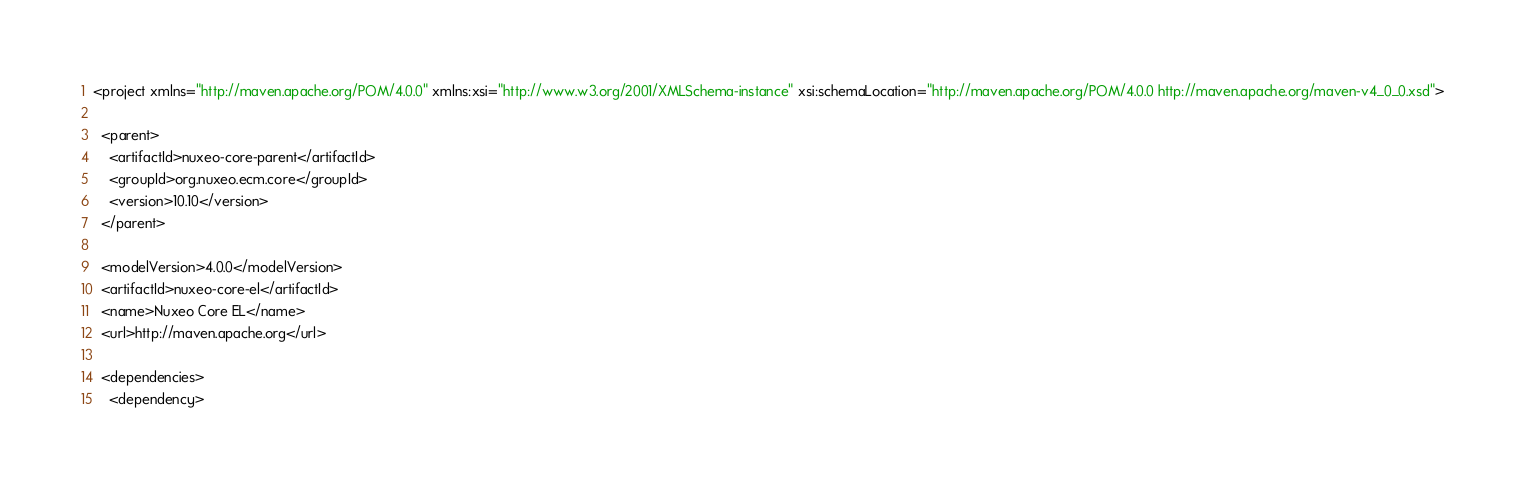Convert code to text. <code><loc_0><loc_0><loc_500><loc_500><_XML_><project xmlns="http://maven.apache.org/POM/4.0.0" xmlns:xsi="http://www.w3.org/2001/XMLSchema-instance" xsi:schemaLocation="http://maven.apache.org/POM/4.0.0 http://maven.apache.org/maven-v4_0_0.xsd">

  <parent>
    <artifactId>nuxeo-core-parent</artifactId>
    <groupId>org.nuxeo.ecm.core</groupId>
    <version>10.10</version>
  </parent>

  <modelVersion>4.0.0</modelVersion>
  <artifactId>nuxeo-core-el</artifactId>
  <name>Nuxeo Core EL</name>
  <url>http://maven.apache.org</url>

  <dependencies>
    <dependency></code> 